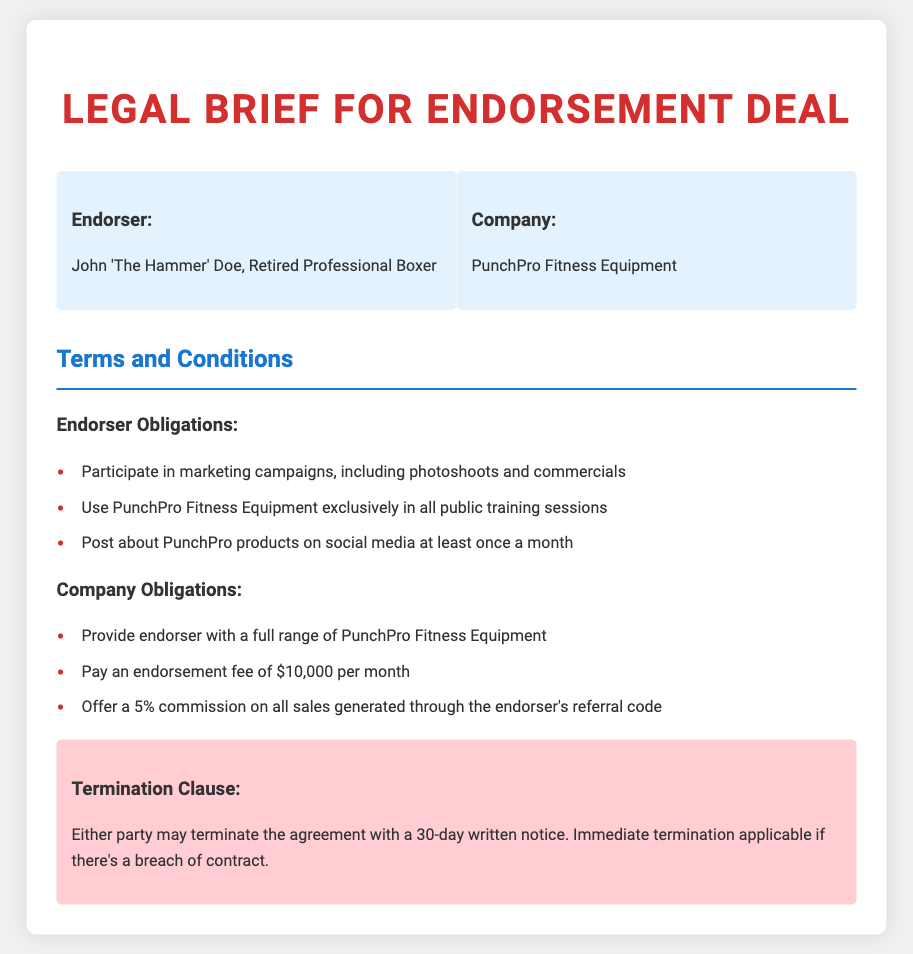What is the name of the endorser? The endorser's name is identified at the beginning of the document.
Answer: John 'The Hammer' Doe What is the name of the company in the endorsement deal? The company's name is mentioned alongside the endorser's information.
Answer: PunchPro Fitness Equipment How much is the endorsement fee per month? The document specifies the monthly payment under the company obligations.
Answer: $10,000 What is the commission percentage on sales from the endorsement? The commission rate is clearly stated under the company obligations section.
Answer: 5% How many days notice is needed for termination? The termination clause indicates the notice period for either party during contract termination.
Answer: 30-day What exclusive requirement is placed on the endorser regarding equipment usage? The obligations of the endorser include this exclusive requirement.
Answer: Use PunchPro Fitness Equipment exclusively What must the endorser do on social media at least once a month? The endorser's social media obligation is listed under their responsibilities.
Answer: Post about PunchPro products What happens if there is a breach of contract? The termination clause outlines the consequences of specific actions.
Answer: Immediate termination applicable What should the company provide to the endorser? The obligations of the company detail what they must supply to the endorser.
Answer: Full range of PunchPro Fitness Equipment 